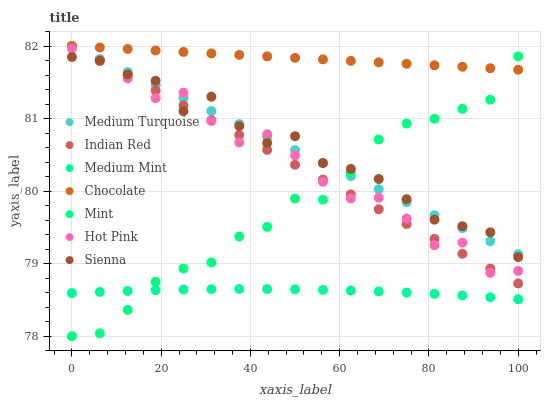Does Medium Mint have the minimum area under the curve?
Answer yes or no. Yes. Does Chocolate have the maximum area under the curve?
Answer yes or no. Yes. Does Medium Turquoise have the minimum area under the curve?
Answer yes or no. No. Does Medium Turquoise have the maximum area under the curve?
Answer yes or no. No. Is Medium Turquoise the smoothest?
Answer yes or no. Yes. Is Hot Pink the roughest?
Answer yes or no. Yes. Is Hot Pink the smoothest?
Answer yes or no. No. Is Medium Turquoise the roughest?
Answer yes or no. No. Does Mint have the lowest value?
Answer yes or no. Yes. Does Medium Turquoise have the lowest value?
Answer yes or no. No. Does Indian Red have the highest value?
Answer yes or no. Yes. Does Hot Pink have the highest value?
Answer yes or no. No. Is Hot Pink less than Chocolate?
Answer yes or no. Yes. Is Hot Pink greater than Medium Mint?
Answer yes or no. Yes. Does Medium Turquoise intersect Indian Red?
Answer yes or no. Yes. Is Medium Turquoise less than Indian Red?
Answer yes or no. No. Is Medium Turquoise greater than Indian Red?
Answer yes or no. No. Does Hot Pink intersect Chocolate?
Answer yes or no. No. 